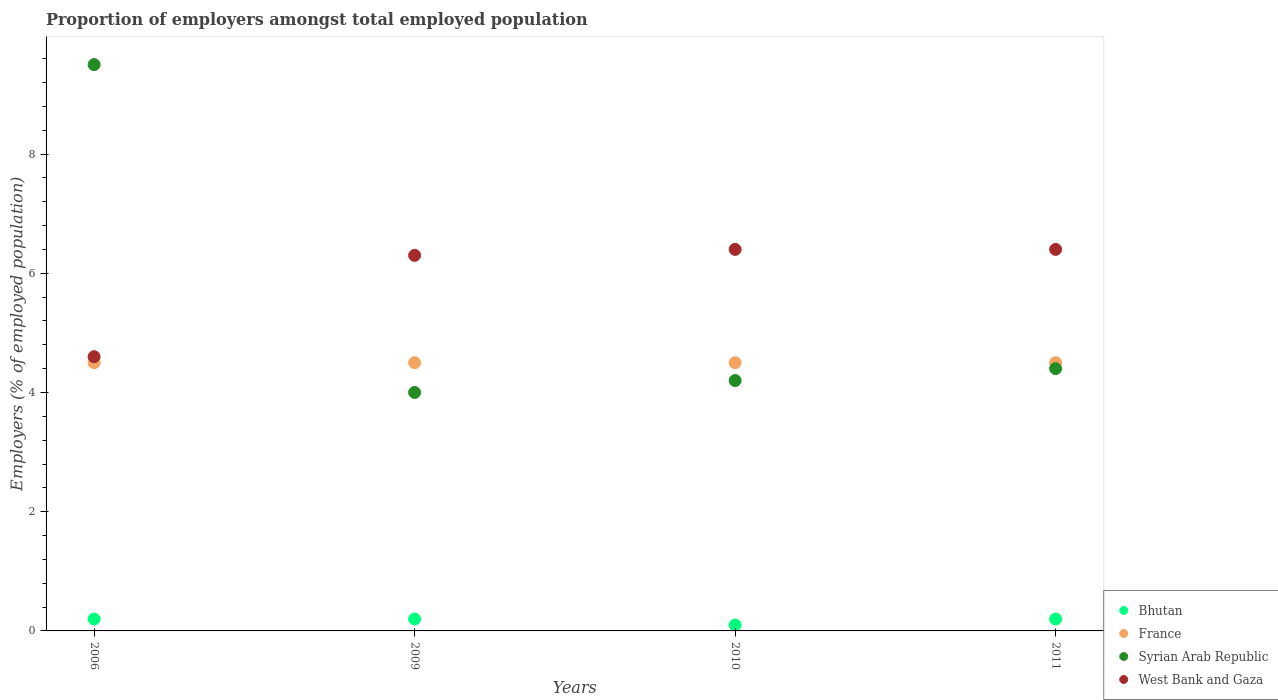Is the number of dotlines equal to the number of legend labels?
Your answer should be very brief. Yes. What is the proportion of employers in France in 2010?
Your answer should be compact. 4.5. Across all years, what is the maximum proportion of employers in Bhutan?
Keep it short and to the point. 0.2. In which year was the proportion of employers in West Bank and Gaza maximum?
Ensure brevity in your answer.  2010. What is the difference between the proportion of employers in Syrian Arab Republic in 2006 and that in 2010?
Offer a very short reply. 5.3. What is the difference between the proportion of employers in Bhutan in 2006 and the proportion of employers in Syrian Arab Republic in 2009?
Keep it short and to the point. -3.8. What is the average proportion of employers in France per year?
Ensure brevity in your answer.  4.5. In the year 2010, what is the difference between the proportion of employers in Syrian Arab Republic and proportion of employers in Bhutan?
Keep it short and to the point. 4.1. What is the ratio of the proportion of employers in Syrian Arab Republic in 2010 to that in 2011?
Provide a succinct answer. 0.95. Is the difference between the proportion of employers in Syrian Arab Republic in 2010 and 2011 greater than the difference between the proportion of employers in Bhutan in 2010 and 2011?
Provide a succinct answer. No. What is the difference between the highest and the second highest proportion of employers in Syrian Arab Republic?
Ensure brevity in your answer.  5.1. What is the difference between the highest and the lowest proportion of employers in Bhutan?
Offer a terse response. 0.1. Is the sum of the proportion of employers in France in 2009 and 2011 greater than the maximum proportion of employers in Syrian Arab Republic across all years?
Your answer should be compact. No. Is it the case that in every year, the sum of the proportion of employers in West Bank and Gaza and proportion of employers in France  is greater than the sum of proportion of employers in Bhutan and proportion of employers in Syrian Arab Republic?
Your answer should be compact. Yes. Is it the case that in every year, the sum of the proportion of employers in Bhutan and proportion of employers in France  is greater than the proportion of employers in Syrian Arab Republic?
Give a very brief answer. No. Is the proportion of employers in France strictly greater than the proportion of employers in Bhutan over the years?
Your response must be concise. Yes. Is the proportion of employers in Bhutan strictly less than the proportion of employers in France over the years?
Keep it short and to the point. Yes. How many dotlines are there?
Your answer should be compact. 4. How many years are there in the graph?
Your answer should be very brief. 4. Does the graph contain any zero values?
Your response must be concise. No. Does the graph contain grids?
Give a very brief answer. No. How are the legend labels stacked?
Keep it short and to the point. Vertical. What is the title of the graph?
Keep it short and to the point. Proportion of employers amongst total employed population. What is the label or title of the X-axis?
Your answer should be compact. Years. What is the label or title of the Y-axis?
Offer a very short reply. Employers (% of employed population). What is the Employers (% of employed population) of Bhutan in 2006?
Your response must be concise. 0.2. What is the Employers (% of employed population) in France in 2006?
Give a very brief answer. 4.5. What is the Employers (% of employed population) of Syrian Arab Republic in 2006?
Keep it short and to the point. 9.5. What is the Employers (% of employed population) in West Bank and Gaza in 2006?
Your answer should be very brief. 4.6. What is the Employers (% of employed population) in Bhutan in 2009?
Offer a terse response. 0.2. What is the Employers (% of employed population) in France in 2009?
Ensure brevity in your answer.  4.5. What is the Employers (% of employed population) of West Bank and Gaza in 2009?
Your answer should be compact. 6.3. What is the Employers (% of employed population) of Bhutan in 2010?
Give a very brief answer. 0.1. What is the Employers (% of employed population) in France in 2010?
Your response must be concise. 4.5. What is the Employers (% of employed population) of Syrian Arab Republic in 2010?
Offer a very short reply. 4.2. What is the Employers (% of employed population) in West Bank and Gaza in 2010?
Your answer should be very brief. 6.4. What is the Employers (% of employed population) of Bhutan in 2011?
Your answer should be compact. 0.2. What is the Employers (% of employed population) of France in 2011?
Offer a very short reply. 4.5. What is the Employers (% of employed population) in Syrian Arab Republic in 2011?
Your answer should be compact. 4.4. What is the Employers (% of employed population) in West Bank and Gaza in 2011?
Your answer should be compact. 6.4. Across all years, what is the maximum Employers (% of employed population) of Bhutan?
Your answer should be very brief. 0.2. Across all years, what is the maximum Employers (% of employed population) of France?
Give a very brief answer. 4.5. Across all years, what is the maximum Employers (% of employed population) in West Bank and Gaza?
Give a very brief answer. 6.4. Across all years, what is the minimum Employers (% of employed population) of Bhutan?
Make the answer very short. 0.1. Across all years, what is the minimum Employers (% of employed population) of France?
Give a very brief answer. 4.5. Across all years, what is the minimum Employers (% of employed population) of West Bank and Gaza?
Your answer should be very brief. 4.6. What is the total Employers (% of employed population) of Bhutan in the graph?
Provide a succinct answer. 0.7. What is the total Employers (% of employed population) in France in the graph?
Keep it short and to the point. 18. What is the total Employers (% of employed population) of Syrian Arab Republic in the graph?
Your answer should be very brief. 22.1. What is the total Employers (% of employed population) in West Bank and Gaza in the graph?
Offer a very short reply. 23.7. What is the difference between the Employers (% of employed population) in Bhutan in 2006 and that in 2009?
Provide a short and direct response. 0. What is the difference between the Employers (% of employed population) of West Bank and Gaza in 2006 and that in 2009?
Offer a very short reply. -1.7. What is the difference between the Employers (% of employed population) of Bhutan in 2006 and that in 2010?
Offer a terse response. 0.1. What is the difference between the Employers (% of employed population) in France in 2006 and that in 2010?
Offer a very short reply. 0. What is the difference between the Employers (% of employed population) of Syrian Arab Republic in 2006 and that in 2010?
Provide a succinct answer. 5.3. What is the difference between the Employers (% of employed population) in West Bank and Gaza in 2006 and that in 2010?
Your answer should be compact. -1.8. What is the difference between the Employers (% of employed population) of France in 2006 and that in 2011?
Ensure brevity in your answer.  0. What is the difference between the Employers (% of employed population) in Bhutan in 2009 and that in 2010?
Offer a terse response. 0.1. What is the difference between the Employers (% of employed population) in Syrian Arab Republic in 2009 and that in 2010?
Offer a terse response. -0.2. What is the difference between the Employers (% of employed population) in West Bank and Gaza in 2009 and that in 2010?
Give a very brief answer. -0.1. What is the difference between the Employers (% of employed population) of Bhutan in 2009 and that in 2011?
Provide a short and direct response. 0. What is the difference between the Employers (% of employed population) in Syrian Arab Republic in 2009 and that in 2011?
Make the answer very short. -0.4. What is the difference between the Employers (% of employed population) of West Bank and Gaza in 2009 and that in 2011?
Make the answer very short. -0.1. What is the difference between the Employers (% of employed population) in Bhutan in 2010 and that in 2011?
Your answer should be compact. -0.1. What is the difference between the Employers (% of employed population) of France in 2010 and that in 2011?
Give a very brief answer. 0. What is the difference between the Employers (% of employed population) of Syrian Arab Republic in 2010 and that in 2011?
Your answer should be compact. -0.2. What is the difference between the Employers (% of employed population) in West Bank and Gaza in 2010 and that in 2011?
Give a very brief answer. 0. What is the difference between the Employers (% of employed population) of Bhutan in 2006 and the Employers (% of employed population) of Syrian Arab Republic in 2009?
Your answer should be compact. -3.8. What is the difference between the Employers (% of employed population) in France in 2006 and the Employers (% of employed population) in West Bank and Gaza in 2009?
Make the answer very short. -1.8. What is the difference between the Employers (% of employed population) of Bhutan in 2006 and the Employers (% of employed population) of Syrian Arab Republic in 2010?
Provide a succinct answer. -4. What is the difference between the Employers (% of employed population) in France in 2006 and the Employers (% of employed population) in Syrian Arab Republic in 2010?
Make the answer very short. 0.3. What is the difference between the Employers (% of employed population) of France in 2006 and the Employers (% of employed population) of West Bank and Gaza in 2010?
Offer a very short reply. -1.9. What is the difference between the Employers (% of employed population) of Syrian Arab Republic in 2006 and the Employers (% of employed population) of West Bank and Gaza in 2010?
Keep it short and to the point. 3.1. What is the difference between the Employers (% of employed population) in Bhutan in 2006 and the Employers (% of employed population) in Syrian Arab Republic in 2011?
Provide a succinct answer. -4.2. What is the difference between the Employers (% of employed population) of Bhutan in 2009 and the Employers (% of employed population) of Syrian Arab Republic in 2010?
Give a very brief answer. -4. What is the difference between the Employers (% of employed population) of Bhutan in 2009 and the Employers (% of employed population) of West Bank and Gaza in 2010?
Keep it short and to the point. -6.2. What is the difference between the Employers (% of employed population) of France in 2009 and the Employers (% of employed population) of West Bank and Gaza in 2010?
Provide a succinct answer. -1.9. What is the difference between the Employers (% of employed population) of Bhutan in 2009 and the Employers (% of employed population) of France in 2011?
Offer a very short reply. -4.3. What is the difference between the Employers (% of employed population) of Bhutan in 2009 and the Employers (% of employed population) of Syrian Arab Republic in 2011?
Your answer should be very brief. -4.2. What is the difference between the Employers (% of employed population) in Bhutan in 2009 and the Employers (% of employed population) in West Bank and Gaza in 2011?
Provide a succinct answer. -6.2. What is the difference between the Employers (% of employed population) of Bhutan in 2010 and the Employers (% of employed population) of France in 2011?
Your response must be concise. -4.4. What is the difference between the Employers (% of employed population) of France in 2010 and the Employers (% of employed population) of West Bank and Gaza in 2011?
Offer a very short reply. -1.9. What is the average Employers (% of employed population) in Bhutan per year?
Offer a terse response. 0.17. What is the average Employers (% of employed population) in France per year?
Make the answer very short. 4.5. What is the average Employers (% of employed population) of Syrian Arab Republic per year?
Your answer should be very brief. 5.53. What is the average Employers (% of employed population) in West Bank and Gaza per year?
Offer a terse response. 5.92. In the year 2006, what is the difference between the Employers (% of employed population) in Bhutan and Employers (% of employed population) in France?
Ensure brevity in your answer.  -4.3. In the year 2006, what is the difference between the Employers (% of employed population) of Bhutan and Employers (% of employed population) of West Bank and Gaza?
Keep it short and to the point. -4.4. In the year 2006, what is the difference between the Employers (% of employed population) in France and Employers (% of employed population) in Syrian Arab Republic?
Keep it short and to the point. -5. In the year 2009, what is the difference between the Employers (% of employed population) in France and Employers (% of employed population) in Syrian Arab Republic?
Your answer should be very brief. 0.5. In the year 2010, what is the difference between the Employers (% of employed population) in Bhutan and Employers (% of employed population) in France?
Ensure brevity in your answer.  -4.4. In the year 2010, what is the difference between the Employers (% of employed population) of France and Employers (% of employed population) of Syrian Arab Republic?
Your answer should be very brief. 0.3. In the year 2010, what is the difference between the Employers (% of employed population) in Syrian Arab Republic and Employers (% of employed population) in West Bank and Gaza?
Give a very brief answer. -2.2. In the year 2011, what is the difference between the Employers (% of employed population) in Bhutan and Employers (% of employed population) in France?
Your response must be concise. -4.3. In the year 2011, what is the difference between the Employers (% of employed population) of Bhutan and Employers (% of employed population) of West Bank and Gaza?
Offer a very short reply. -6.2. In the year 2011, what is the difference between the Employers (% of employed population) in France and Employers (% of employed population) in Syrian Arab Republic?
Provide a succinct answer. 0.1. What is the ratio of the Employers (% of employed population) of Bhutan in 2006 to that in 2009?
Provide a succinct answer. 1. What is the ratio of the Employers (% of employed population) of Syrian Arab Republic in 2006 to that in 2009?
Your answer should be compact. 2.38. What is the ratio of the Employers (% of employed population) of West Bank and Gaza in 2006 to that in 2009?
Provide a succinct answer. 0.73. What is the ratio of the Employers (% of employed population) of France in 2006 to that in 2010?
Make the answer very short. 1. What is the ratio of the Employers (% of employed population) in Syrian Arab Republic in 2006 to that in 2010?
Provide a short and direct response. 2.26. What is the ratio of the Employers (% of employed population) of West Bank and Gaza in 2006 to that in 2010?
Offer a terse response. 0.72. What is the ratio of the Employers (% of employed population) in Bhutan in 2006 to that in 2011?
Keep it short and to the point. 1. What is the ratio of the Employers (% of employed population) of Syrian Arab Republic in 2006 to that in 2011?
Provide a short and direct response. 2.16. What is the ratio of the Employers (% of employed population) in West Bank and Gaza in 2006 to that in 2011?
Keep it short and to the point. 0.72. What is the ratio of the Employers (% of employed population) of France in 2009 to that in 2010?
Provide a succinct answer. 1. What is the ratio of the Employers (% of employed population) in West Bank and Gaza in 2009 to that in 2010?
Ensure brevity in your answer.  0.98. What is the ratio of the Employers (% of employed population) of Bhutan in 2009 to that in 2011?
Your response must be concise. 1. What is the ratio of the Employers (% of employed population) of France in 2009 to that in 2011?
Provide a succinct answer. 1. What is the ratio of the Employers (% of employed population) in Syrian Arab Republic in 2009 to that in 2011?
Your answer should be very brief. 0.91. What is the ratio of the Employers (% of employed population) of West Bank and Gaza in 2009 to that in 2011?
Your answer should be very brief. 0.98. What is the ratio of the Employers (% of employed population) of France in 2010 to that in 2011?
Give a very brief answer. 1. What is the ratio of the Employers (% of employed population) in Syrian Arab Republic in 2010 to that in 2011?
Provide a short and direct response. 0.95. What is the ratio of the Employers (% of employed population) of West Bank and Gaza in 2010 to that in 2011?
Your answer should be very brief. 1. What is the difference between the highest and the second highest Employers (% of employed population) in France?
Give a very brief answer. 0. What is the difference between the highest and the lowest Employers (% of employed population) of Syrian Arab Republic?
Provide a short and direct response. 5.5. What is the difference between the highest and the lowest Employers (% of employed population) of West Bank and Gaza?
Offer a terse response. 1.8. 